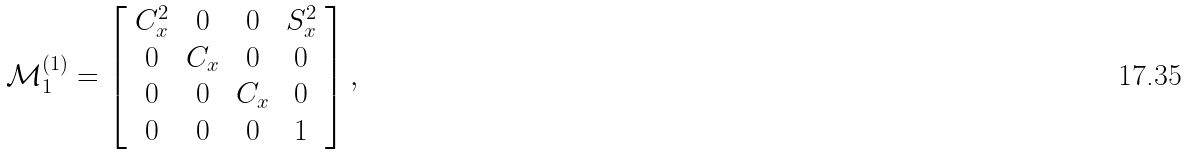<formula> <loc_0><loc_0><loc_500><loc_500>\mathcal { M } _ { 1 } ^ { ( 1 ) } = \left [ \begin{array} { c c c c } C _ { x } ^ { 2 } & 0 & 0 & S _ { x } ^ { 2 } \\ 0 & C _ { x } & 0 & 0 \\ 0 & 0 & C _ { x } & 0 \\ 0 & 0 & 0 & 1 \end{array} \right ] ,</formula> 